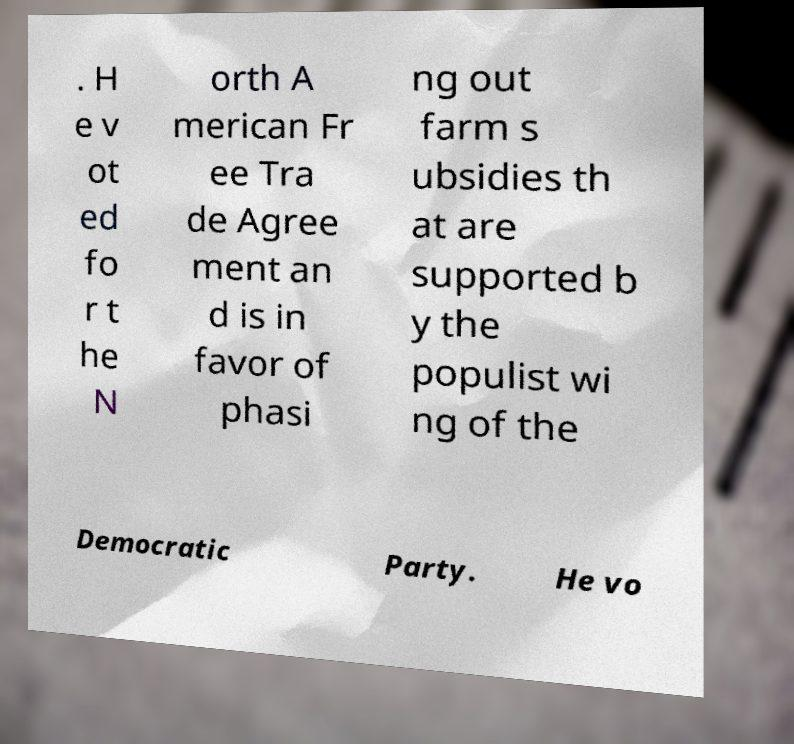There's text embedded in this image that I need extracted. Can you transcribe it verbatim? . H e v ot ed fo r t he N orth A merican Fr ee Tra de Agree ment an d is in favor of phasi ng out farm s ubsidies th at are supported b y the populist wi ng of the Democratic Party. He vo 